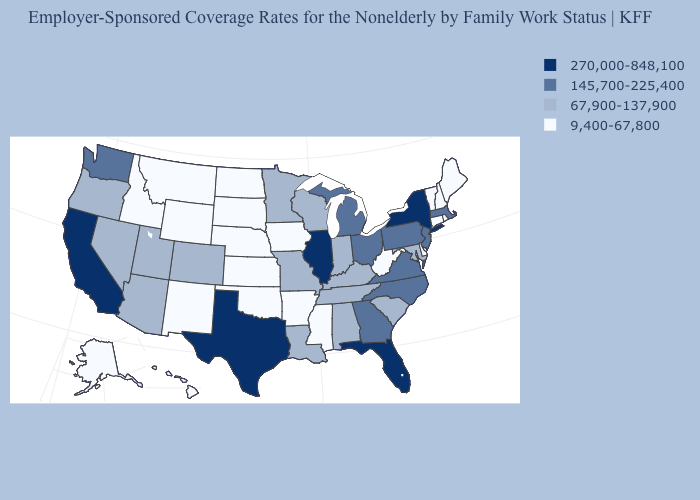What is the value of New Hampshire?
Short answer required. 9,400-67,800. What is the highest value in states that border South Dakota?
Keep it brief. 67,900-137,900. Is the legend a continuous bar?
Give a very brief answer. No. Name the states that have a value in the range 67,900-137,900?
Be succinct. Alabama, Arizona, Colorado, Indiana, Kentucky, Louisiana, Maryland, Minnesota, Missouri, Nevada, Oregon, South Carolina, Tennessee, Utah, Wisconsin. Which states have the highest value in the USA?
Concise answer only. California, Florida, Illinois, New York, Texas. Is the legend a continuous bar?
Give a very brief answer. No. Among the states that border Maryland , does West Virginia have the highest value?
Write a very short answer. No. Does Idaho have a lower value than New York?
Be succinct. Yes. Does Oklahoma have the same value as Kentucky?
Keep it brief. No. Name the states that have a value in the range 9,400-67,800?
Give a very brief answer. Alaska, Arkansas, Connecticut, Delaware, Hawaii, Idaho, Iowa, Kansas, Maine, Mississippi, Montana, Nebraska, New Hampshire, New Mexico, North Dakota, Oklahoma, Rhode Island, South Dakota, Vermont, West Virginia, Wyoming. Does Texas have the highest value in the USA?
Answer briefly. Yes. What is the lowest value in the USA?
Short answer required. 9,400-67,800. What is the value of South Carolina?
Be succinct. 67,900-137,900. Does Florida have the highest value in the USA?
Give a very brief answer. Yes. What is the lowest value in states that border Iowa?
Answer briefly. 9,400-67,800. 